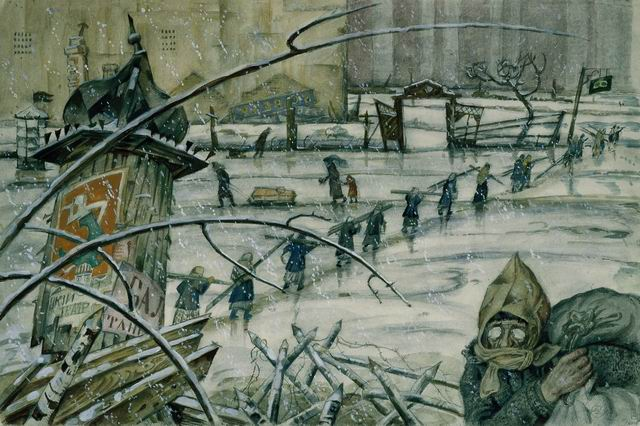What kind of scenarios can you imagine happening next in this scene? Scenario 1 (Short): The group of people might find temporary shelter in a nearby building, where they share stories, food, and warmth, forging a sense of community amidst the chaos. 
Scenario 2 (Long): As they continue their journey, the group encounters a checkpoint guarded by soldiers. They are questioned and their belongings inspected. Despite the tension, they are eventually allowed to pass. Later, they discover an old warehouse that provides some respite. There, an elderly man shares tales of the city’s heyday and offers advice on safe routes out of the war-torn area. The group bonds over their shared experiences, finding solace and strength in their unity as they plan their next move towards safety and recovery. 